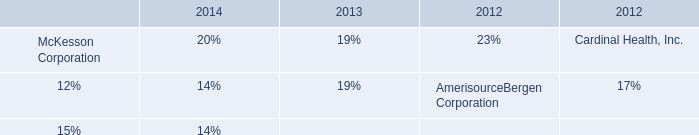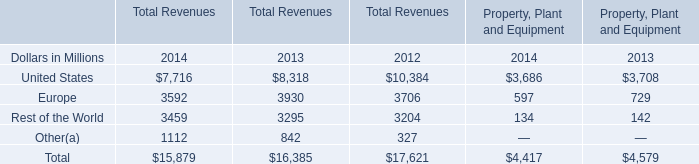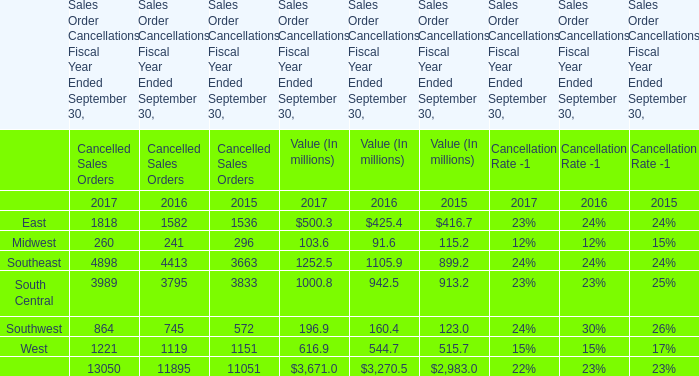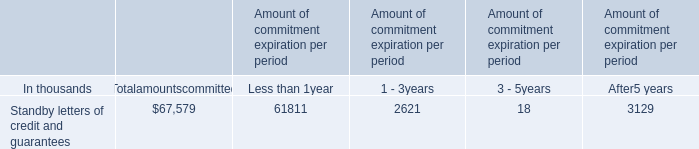Which year / section is Midwest in Value (In millions) in the lowest? 
Answer: 2016. 